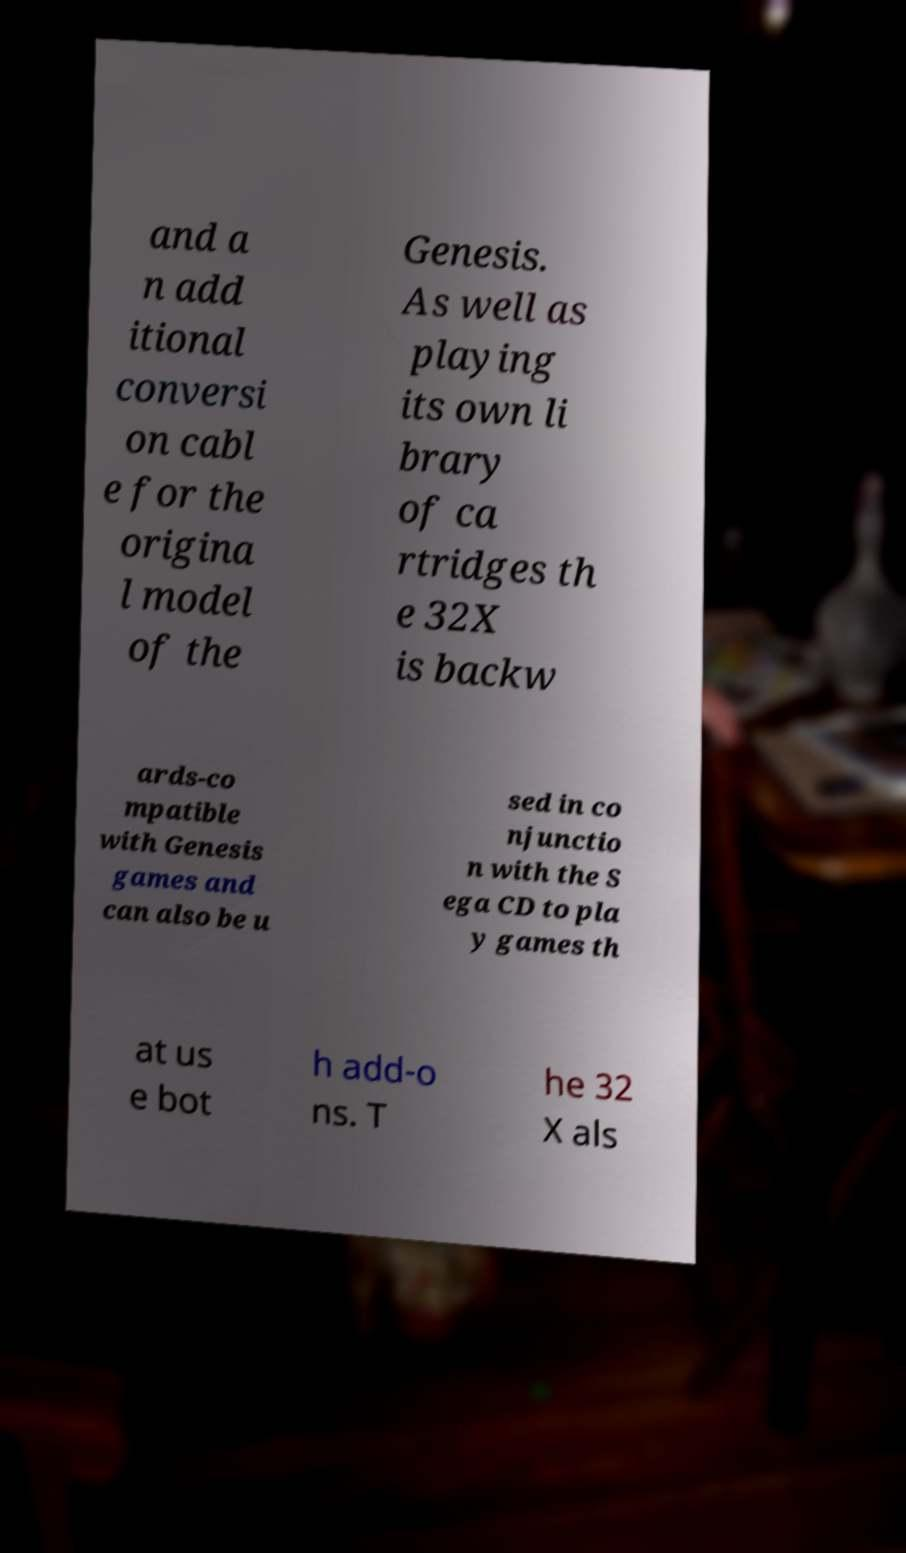Could you extract and type out the text from this image? and a n add itional conversi on cabl e for the origina l model of the Genesis. As well as playing its own li brary of ca rtridges th e 32X is backw ards-co mpatible with Genesis games and can also be u sed in co njunctio n with the S ega CD to pla y games th at us e bot h add-o ns. T he 32 X als 